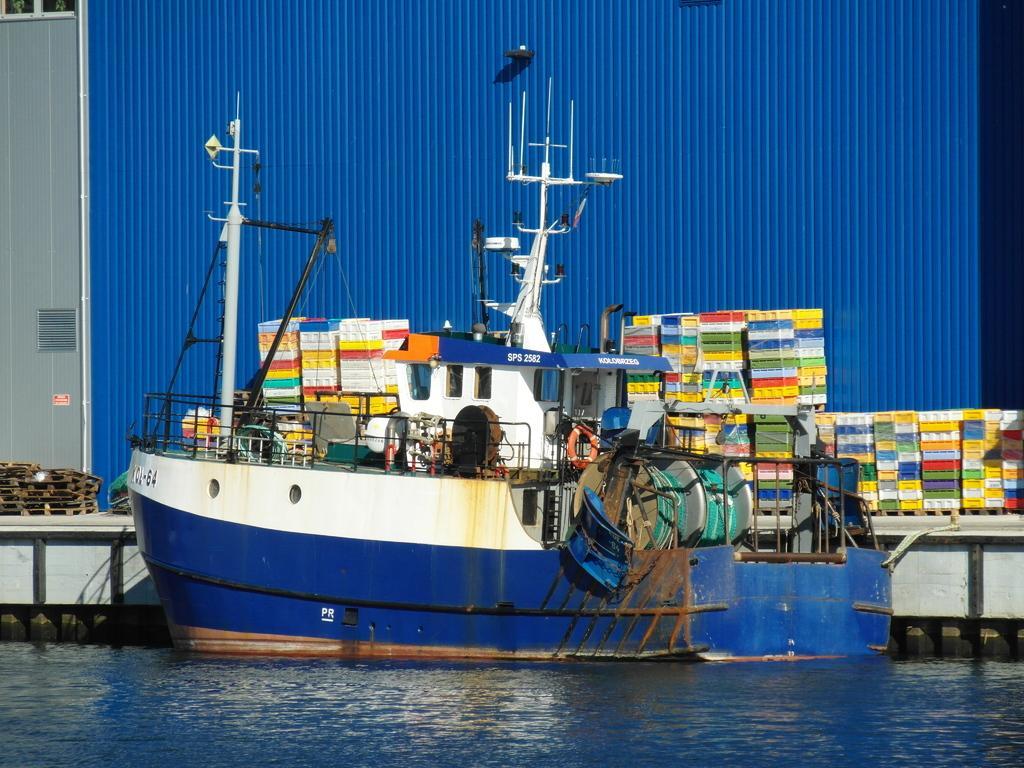Describe this image in one or two sentences. In this picture we can see a boat on the water and on the boat there is a lifebuoy. Behind the boat there are plastic objects, blue iron sheet and other objects. 